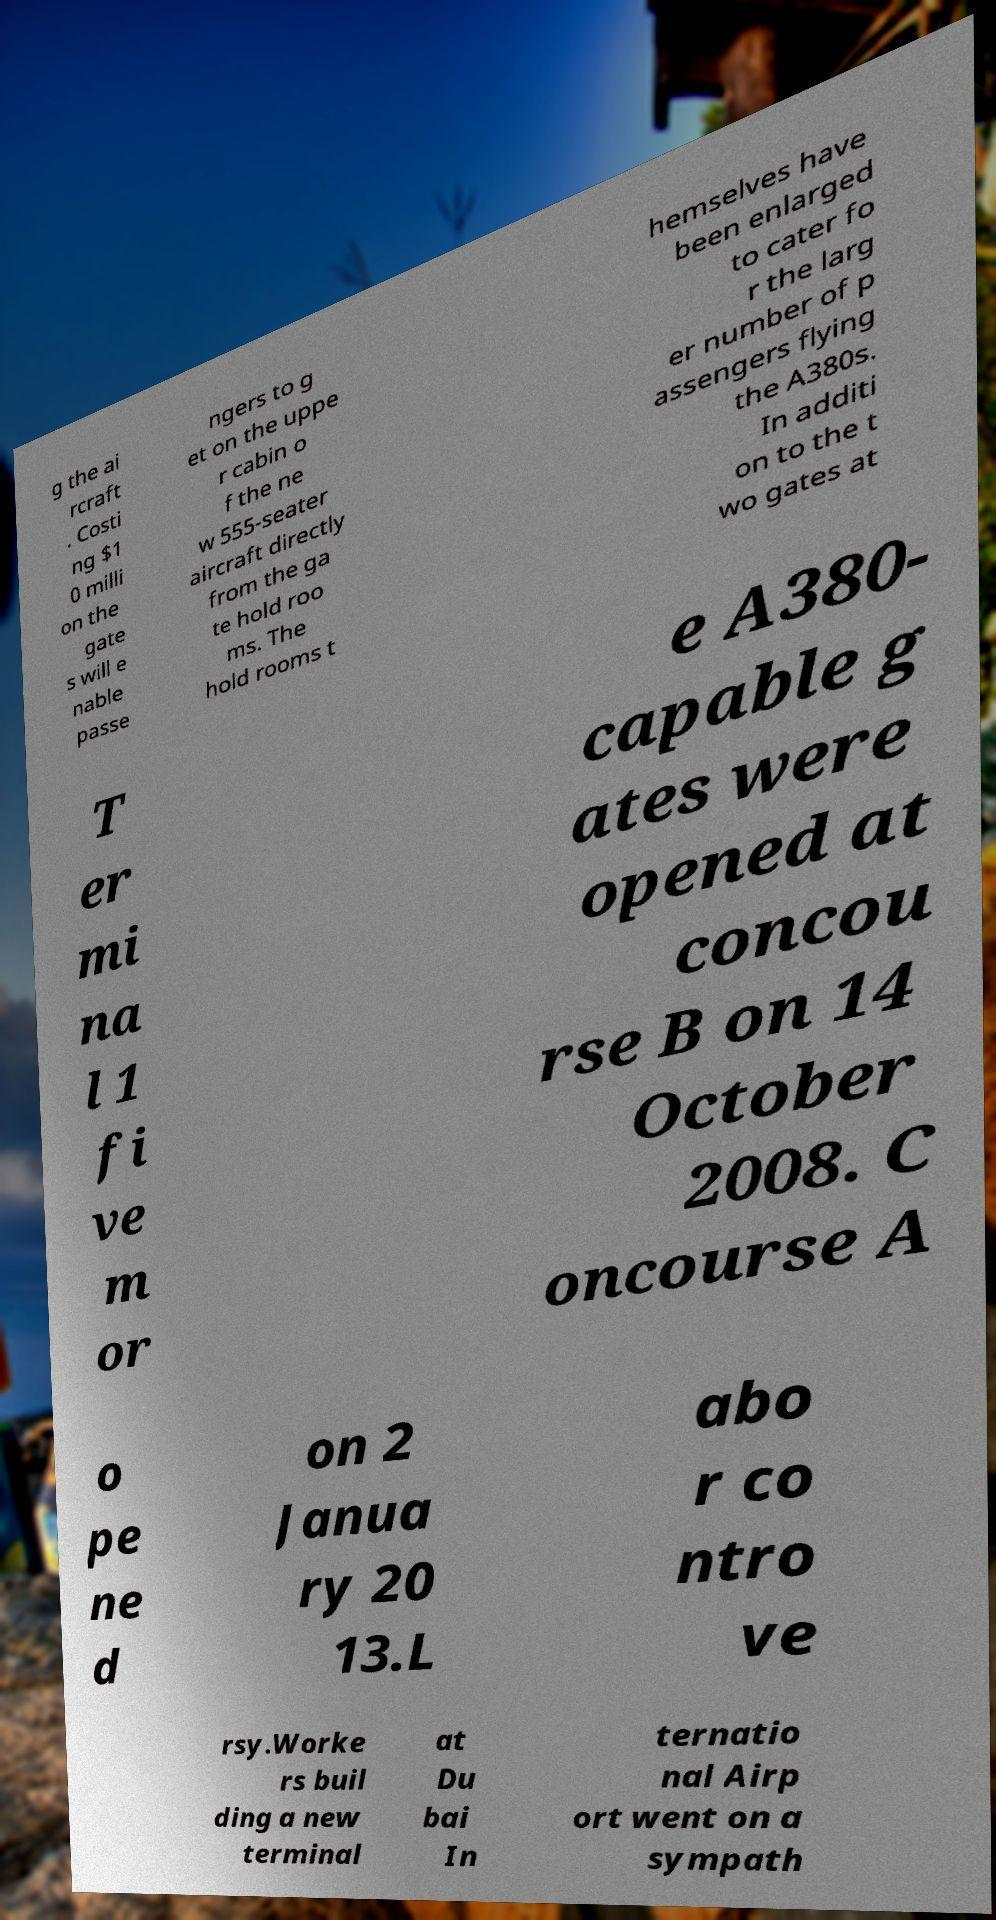What messages or text are displayed in this image? I need them in a readable, typed format. g the ai rcraft . Costi ng $1 0 milli on the gate s will e nable passe ngers to g et on the uppe r cabin o f the ne w 555-seater aircraft directly from the ga te hold roo ms. The hold rooms t hemselves have been enlarged to cater fo r the larg er number of p assengers flying the A380s. In additi on to the t wo gates at T er mi na l 1 fi ve m or e A380- capable g ates were opened at concou rse B on 14 October 2008. C oncourse A o pe ne d on 2 Janua ry 20 13.L abo r co ntro ve rsy.Worke rs buil ding a new terminal at Du bai In ternatio nal Airp ort went on a sympath 